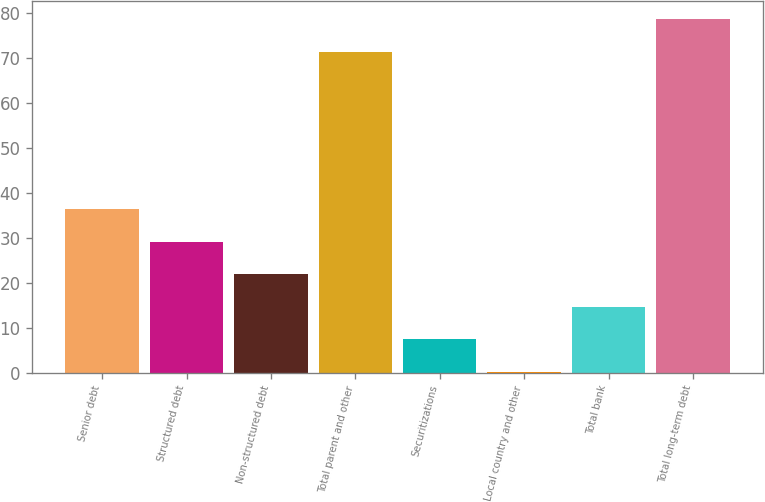<chart> <loc_0><loc_0><loc_500><loc_500><bar_chart><fcel>Senior debt<fcel>Structured debt<fcel>Non-structured debt<fcel>Total parent and other<fcel>Securitizations<fcel>Local country and other<fcel>Total bank<fcel>Total long-term debt<nl><fcel>36.4<fcel>29.16<fcel>21.92<fcel>71.5<fcel>7.44<fcel>0.2<fcel>14.68<fcel>78.74<nl></chart> 